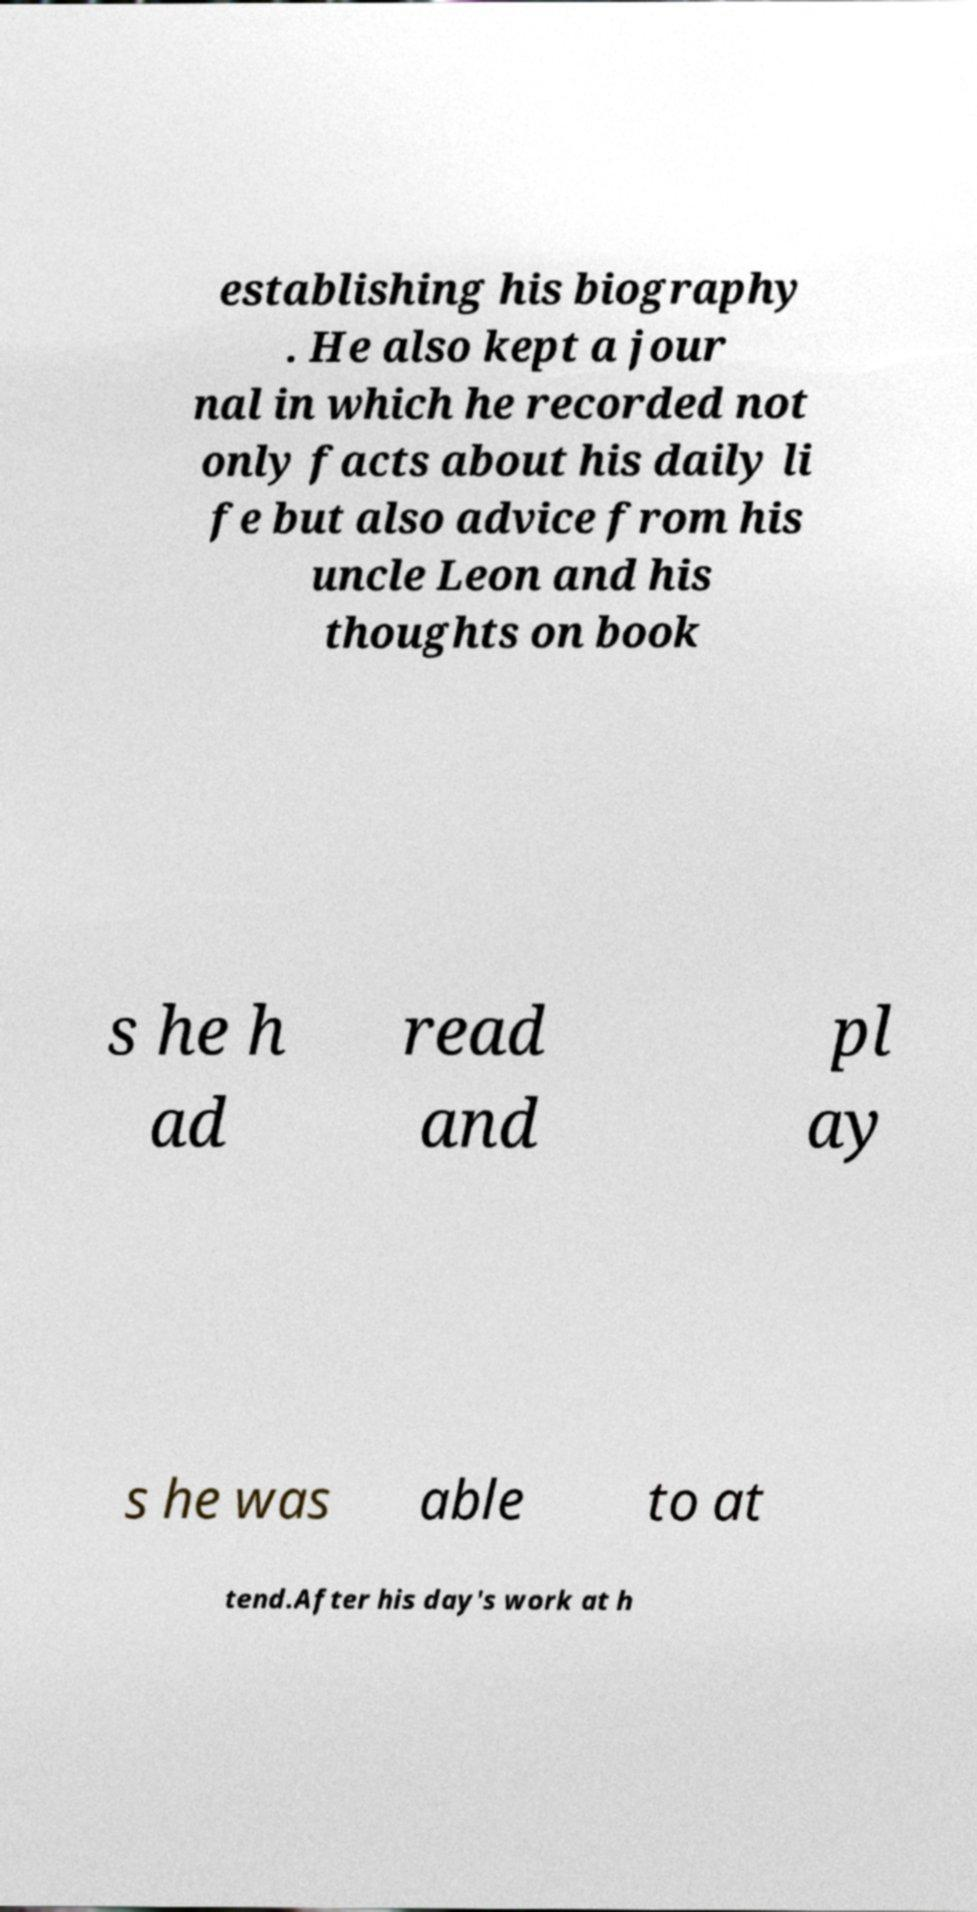What messages or text are displayed in this image? I need them in a readable, typed format. establishing his biography . He also kept a jour nal in which he recorded not only facts about his daily li fe but also advice from his uncle Leon and his thoughts on book s he h ad read and pl ay s he was able to at tend.After his day's work at h 